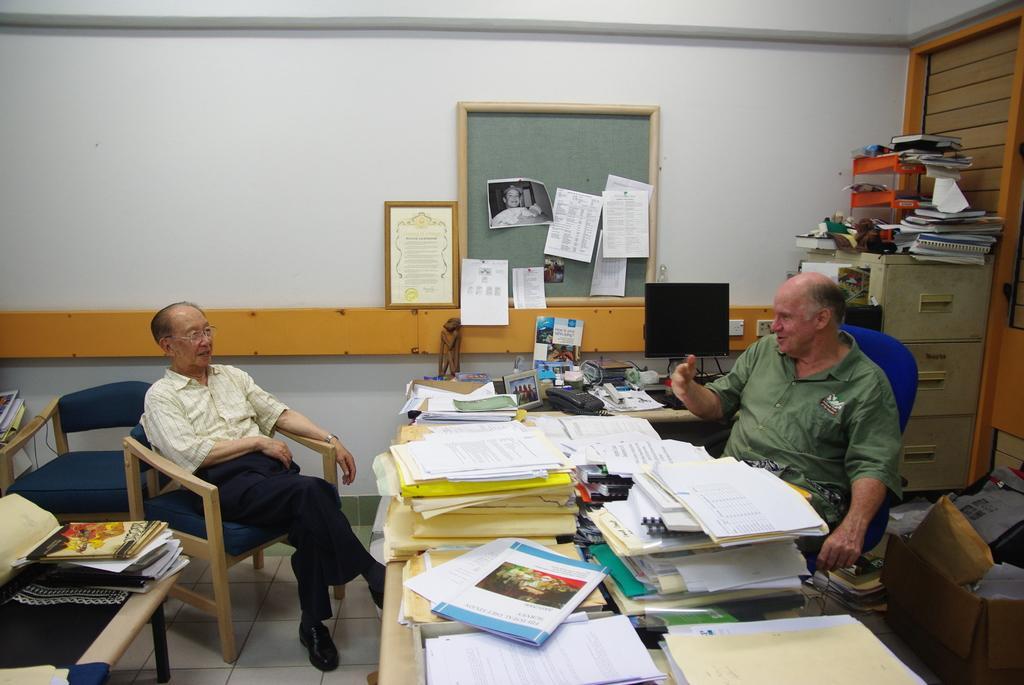In one or two sentences, can you explain what this image depicts? Man on the right is sitting on a chair. In front of him there is a table. On the table there are many books , papers, telephone, computer, photo frame and many other items. In front of him another person sitting on chair. Also there is another table on the left. On the table there are books. In the background there is a wall with a board. On the board there are many notices. On the corner there is a cupboard with lot of books kept. On the floor there are boxes. In side the boxes there are many books and some other items. 